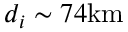Convert formula to latex. <formula><loc_0><loc_0><loc_500><loc_500>d _ { i } \sim 7 4 { k m }</formula> 